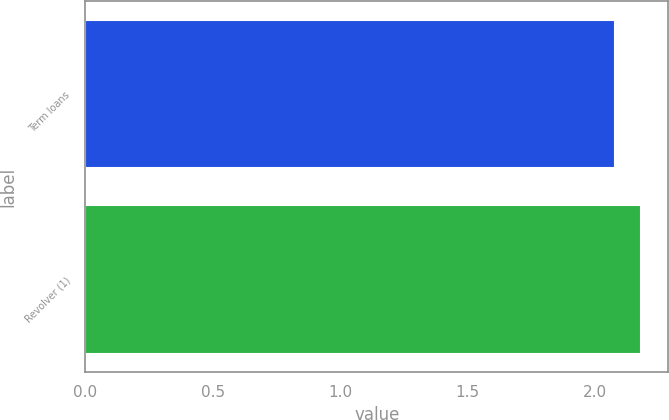Convert chart. <chart><loc_0><loc_0><loc_500><loc_500><bar_chart><fcel>Term loans<fcel>Revolver (1)<nl><fcel>2.08<fcel>2.18<nl></chart> 